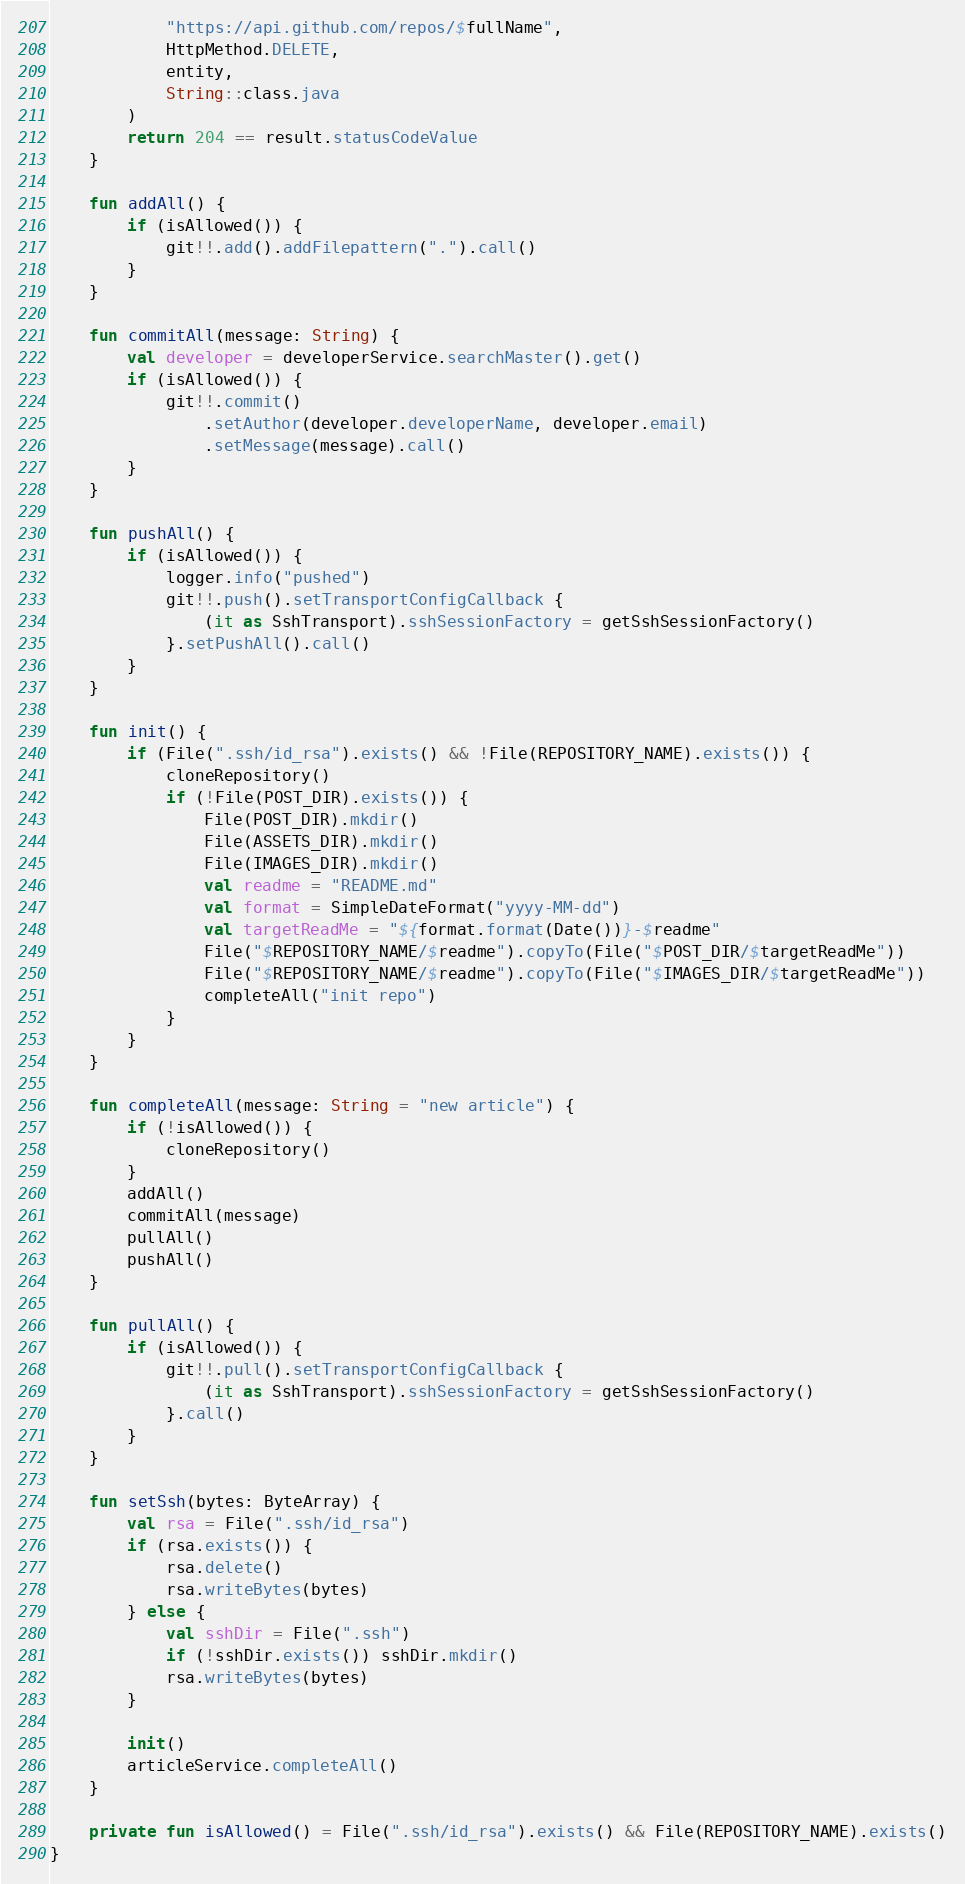Convert code to text. <code><loc_0><loc_0><loc_500><loc_500><_Kotlin_>            "https://api.github.com/repos/$fullName",
            HttpMethod.DELETE,
            entity,
            String::class.java
        )
        return 204 == result.statusCodeValue
    }

    fun addAll() {
        if (isAllowed()) {
            git!!.add().addFilepattern(".").call()
        }
    }

    fun commitAll(message: String) {
        val developer = developerService.searchMaster().get()
        if (isAllowed()) {
            git!!.commit()
                .setAuthor(developer.developerName, developer.email)
                .setMessage(message).call()
        }
    }

    fun pushAll() {
        if (isAllowed()) {
            logger.info("pushed")
            git!!.push().setTransportConfigCallback {
                (it as SshTransport).sshSessionFactory = getSshSessionFactory()
            }.setPushAll().call()
        }
    }

    fun init() {
        if (File(".ssh/id_rsa").exists() && !File(REPOSITORY_NAME).exists()) {
            cloneRepository()
            if (!File(POST_DIR).exists()) {
                File(POST_DIR).mkdir()
                File(ASSETS_DIR).mkdir()
                File(IMAGES_DIR).mkdir()
                val readme = "README.md"
                val format = SimpleDateFormat("yyyy-MM-dd")
                val targetReadMe = "${format.format(Date())}-$readme"
                File("$REPOSITORY_NAME/$readme").copyTo(File("$POST_DIR/$targetReadMe"))
                File("$REPOSITORY_NAME/$readme").copyTo(File("$IMAGES_DIR/$targetReadMe"))
                completeAll("init repo")
            }
        }
    }

    fun completeAll(message: String = "new article") {
        if (!isAllowed()) {
            cloneRepository()
        }
        addAll()
        commitAll(message)
        pullAll()
        pushAll()
    }

    fun pullAll() {
        if (isAllowed()) {
            git!!.pull().setTransportConfigCallback {
                (it as SshTransport).sshSessionFactory = getSshSessionFactory()
            }.call()
        }
    }

    fun setSsh(bytes: ByteArray) {
        val rsa = File(".ssh/id_rsa")
        if (rsa.exists()) {
            rsa.delete()
            rsa.writeBytes(bytes)
        } else {
            val sshDir = File(".ssh")
            if (!sshDir.exists()) sshDir.mkdir()
            rsa.writeBytes(bytes)
        }

        init()
        articleService.completeAll()
    }

    private fun isAllowed() = File(".ssh/id_rsa").exists() && File(REPOSITORY_NAME).exists()
}</code> 